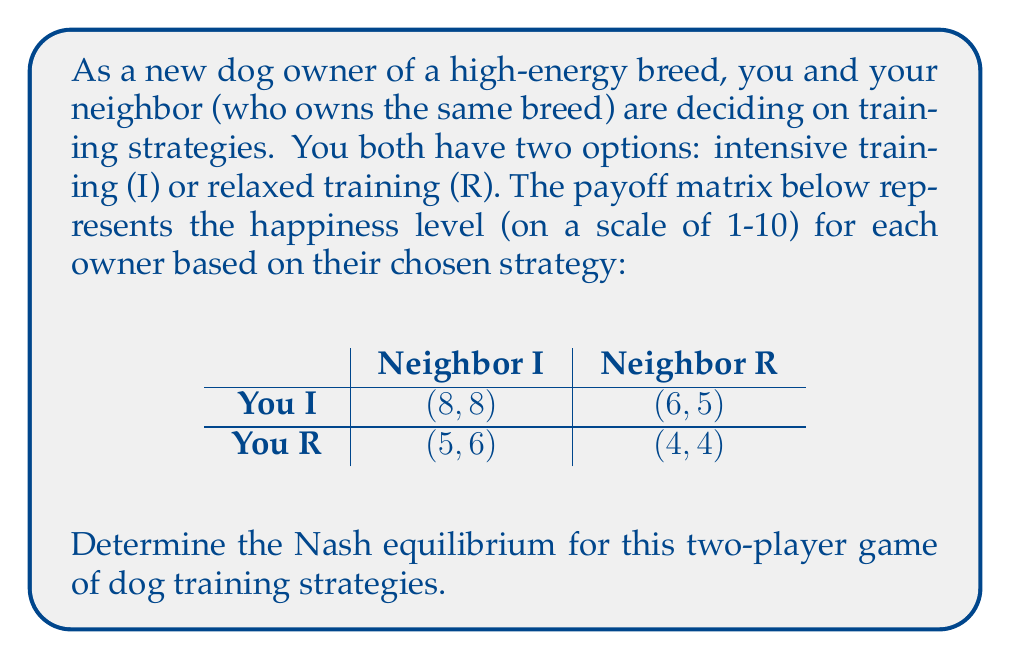Help me with this question. To find the Nash equilibrium, we need to identify the strategy pairs where neither player has an incentive to unilaterally change their strategy.

Let's analyze each player's best responses:

1. Your perspective:
   - If Neighbor chooses I: Your best response is I (8 > 5)
   - If Neighbor chooses R: Your best response is I (6 > 4)

2. Neighbor's perspective:
   - If You choose I: Neighbor's best response is I (8 > 5)
   - If You choose R: Neighbor's best response is I (6 > 4)

We can see that regardless of what the other player does, both you and your neighbor always prefer the intensive training strategy (I).

The Nash equilibrium occurs when both players choose their best response to the other player's strategy. In this case, when both players choose I, neither has an incentive to switch to R unilaterally.

Therefore, the Nash equilibrium is (I, I), resulting in a payoff of (8, 8).

This equilibrium suggests that for high-energy dog breeds, intensive training leads to higher satisfaction for both owners, as it likely results in better-behaved dogs and a more harmonious neighborhood.
Answer: The Nash equilibrium is (I, I), with both owners choosing intensive training, resulting in a payoff of (8, 8). 